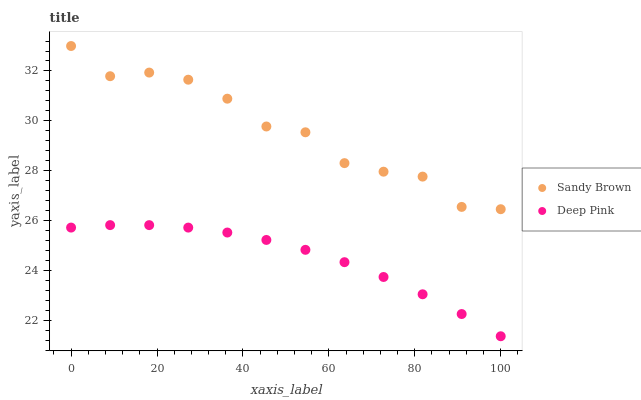Does Deep Pink have the minimum area under the curve?
Answer yes or no. Yes. Does Sandy Brown have the maximum area under the curve?
Answer yes or no. Yes. Does Sandy Brown have the minimum area under the curve?
Answer yes or no. No. Is Deep Pink the smoothest?
Answer yes or no. Yes. Is Sandy Brown the roughest?
Answer yes or no. Yes. Is Sandy Brown the smoothest?
Answer yes or no. No. Does Deep Pink have the lowest value?
Answer yes or no. Yes. Does Sandy Brown have the lowest value?
Answer yes or no. No. Does Sandy Brown have the highest value?
Answer yes or no. Yes. Is Deep Pink less than Sandy Brown?
Answer yes or no. Yes. Is Sandy Brown greater than Deep Pink?
Answer yes or no. Yes. Does Deep Pink intersect Sandy Brown?
Answer yes or no. No. 